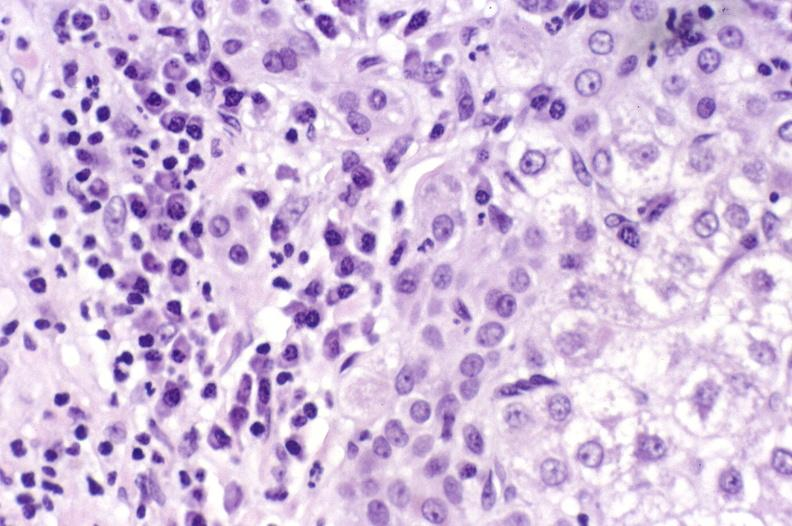s lymphoid atrophy in newborn present?
Answer the question using a single word or phrase. No 